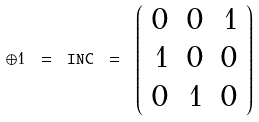<formula> <loc_0><loc_0><loc_500><loc_500>\oplus 1 \ = \ { \tt I N C } \ = \ \left ( \begin{array} { r r r } 0 & 0 & 1 \\ 1 & 0 & 0 \\ 0 & 1 & 0 \\ \end{array} \right )</formula> 